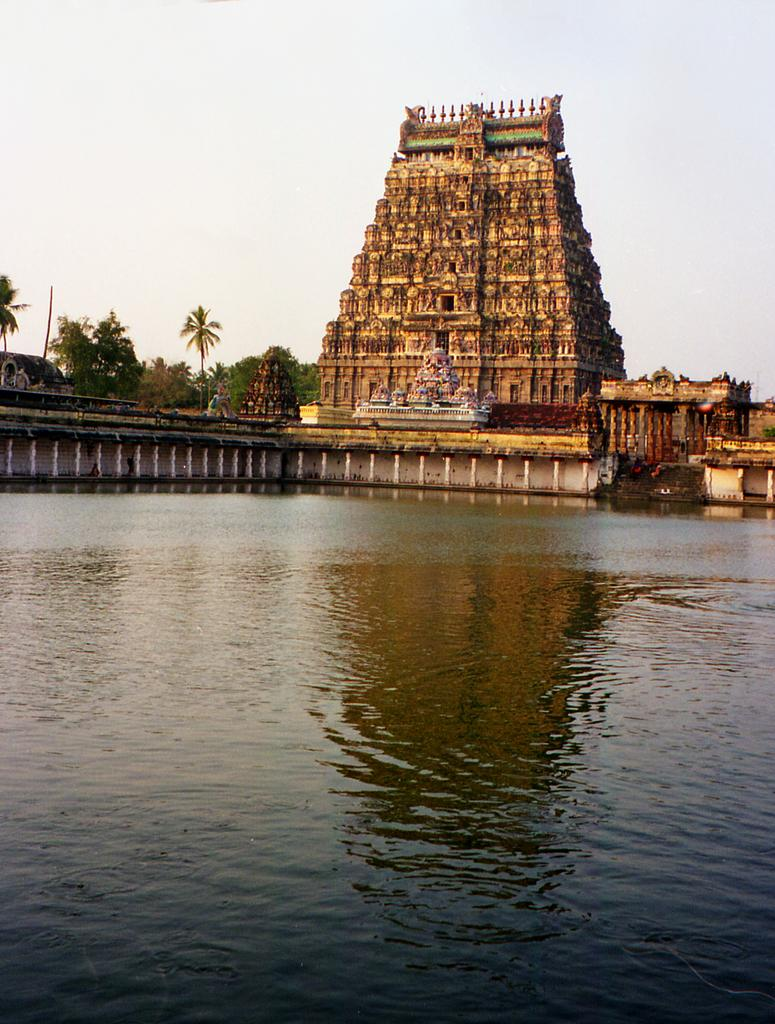What type of structure is present in the image? There is a temple in the image. What other natural elements can be seen in the image? There are trees in the image. What is the condition of the sky in the background of the image? The sky is clear in the background of the image. What is visible in the foreground of the image? There is water visible in the foreground of the image. Where is the faucet located in the image? There is no faucet present in the image. Can you see a game of chess being played in the image? There is no game of chess visible in the image. 